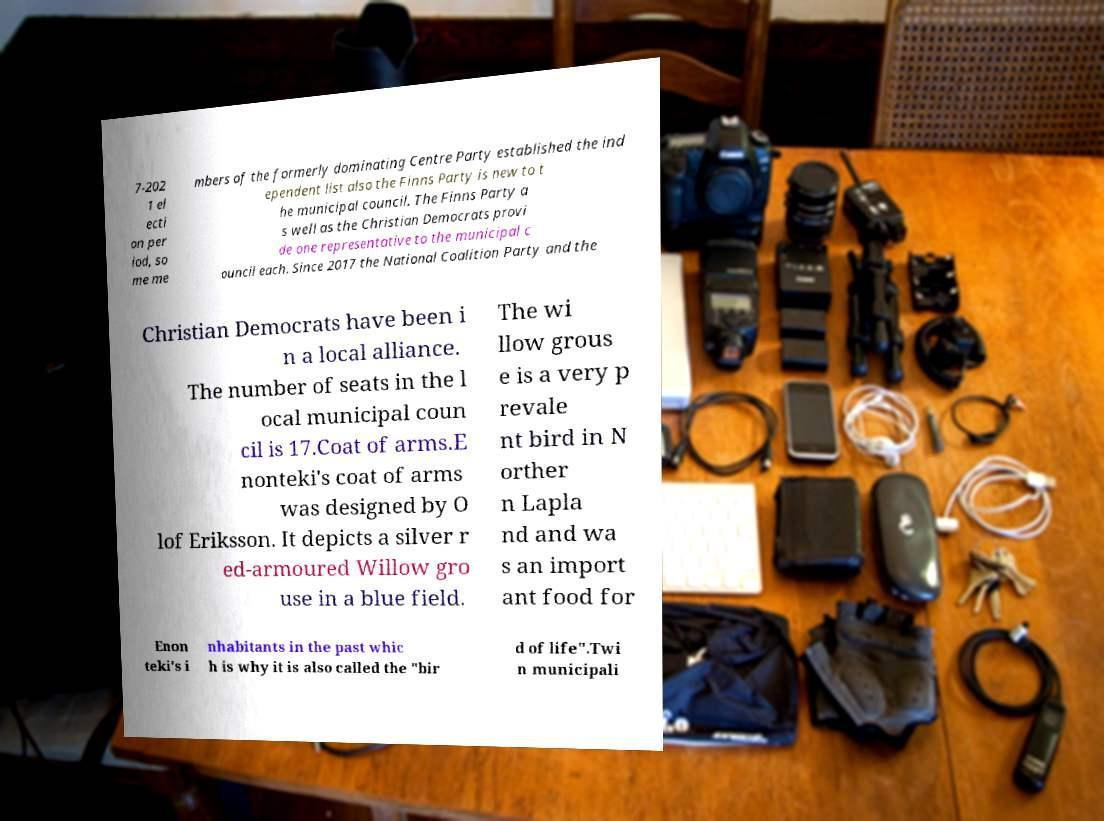Can you read and provide the text displayed in the image?This photo seems to have some interesting text. Can you extract and type it out for me? 7-202 1 el ecti on per iod, so me me mbers of the formerly dominating Centre Party established the ind ependent list also the Finns Party is new to t he municipal council. The Finns Party a s well as the Christian Democrats provi de one representative to the municipal c ouncil each. Since 2017 the National Coalition Party and the Christian Democrats have been i n a local alliance. The number of seats in the l ocal municipal coun cil is 17.Coat of arms.E nonteki's coat of arms was designed by O lof Eriksson. It depicts a silver r ed-armoured Willow gro use in a blue field. The wi llow grous e is a very p revale nt bird in N orther n Lapla nd and wa s an import ant food for Enon teki's i nhabitants in the past whic h is why it is also called the "bir d of life".Twi n municipali 